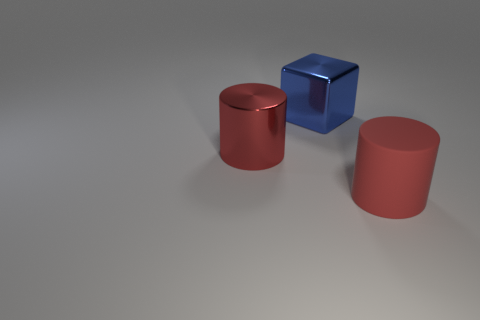Subtract 1 cubes. How many cubes are left? 0 Add 1 big yellow metallic things. How many objects exist? 4 Subtract all blocks. How many objects are left? 2 Subtract 0 purple cubes. How many objects are left? 3 Subtract all blue cylinders. Subtract all yellow blocks. How many cylinders are left? 2 Subtract all blue shiny blocks. Subtract all large blue metallic blocks. How many objects are left? 1 Add 2 big blue things. How many big blue things are left? 3 Add 3 large metal things. How many large metal things exist? 5 